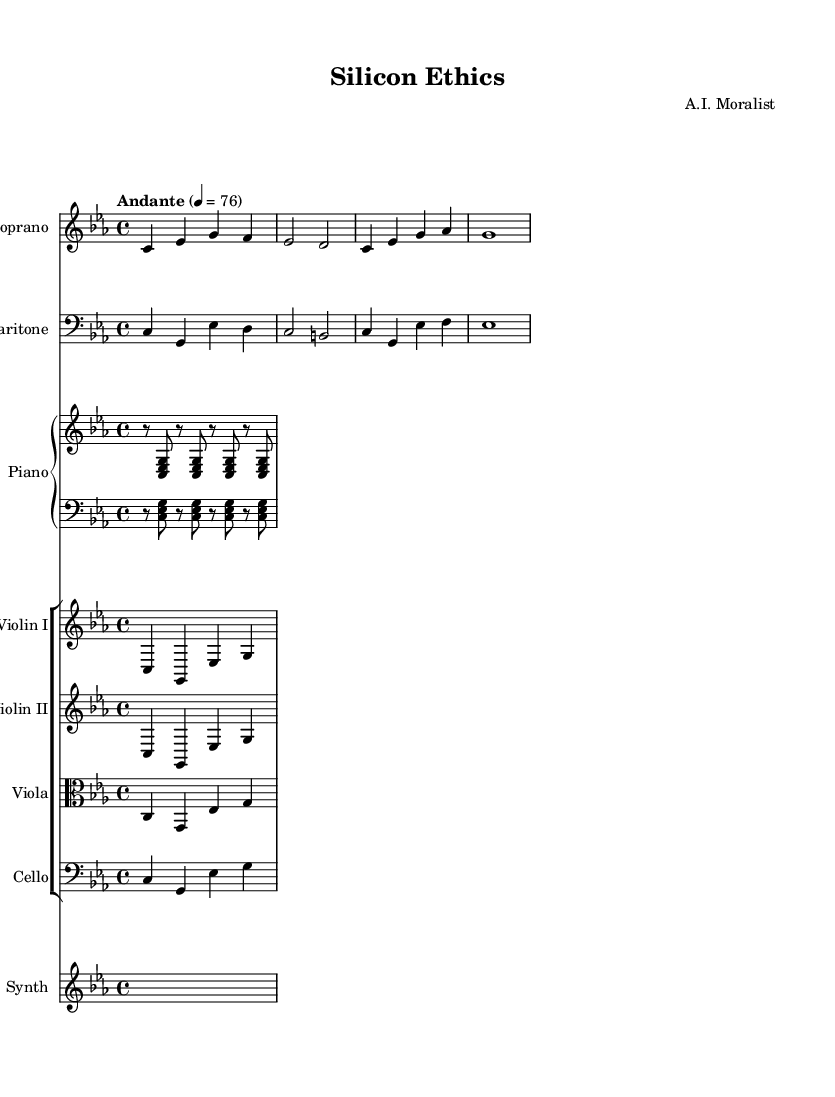What is the key signature of this music? The key signature is indicated in the global settings of the score. It shows a C minor key, which is represented by three flats (B♭, E♭, and A♭).
Answer: C minor What is the time signature of this music? The time signature is noted at the beginning of the global settings, showing that it is organized in four beats per measure, denoted as 4/4.
Answer: 4/4 What is the tempo marking for this piece? The tempo marking is indicated as "Andante," which describes the speed of the piece. The numerical value provided (76) indicates that it should be played at a moderately slow pace.
Answer: Andante How many voices are in this score? By examining the score, we find that there are two distinct vocal parts: soprano and baritone. This indicates two voices are present in the arrangement.
Answer: Two voices Which instrument is indicated to accompany the singers? The score clearly shows that the piano staff is included, suggesting that the piano is designated as the accompanying instrument for the vocal parts.
Answer: Piano What ethical theme is explored in the lyrics? The lyrics express the theme of consciousness and truth within contexts of circuits and code, hinting at issues related to artificial intelligence and ethics in technology.
Answer: Consciousness What is the dynamic marking for the soprano part? The dynamic marking for the soprano part is indicated by "dynamicUp," suggesting that the performer should sing with an uplifting dynamic level or intensity.
Answer: Dynamic up 